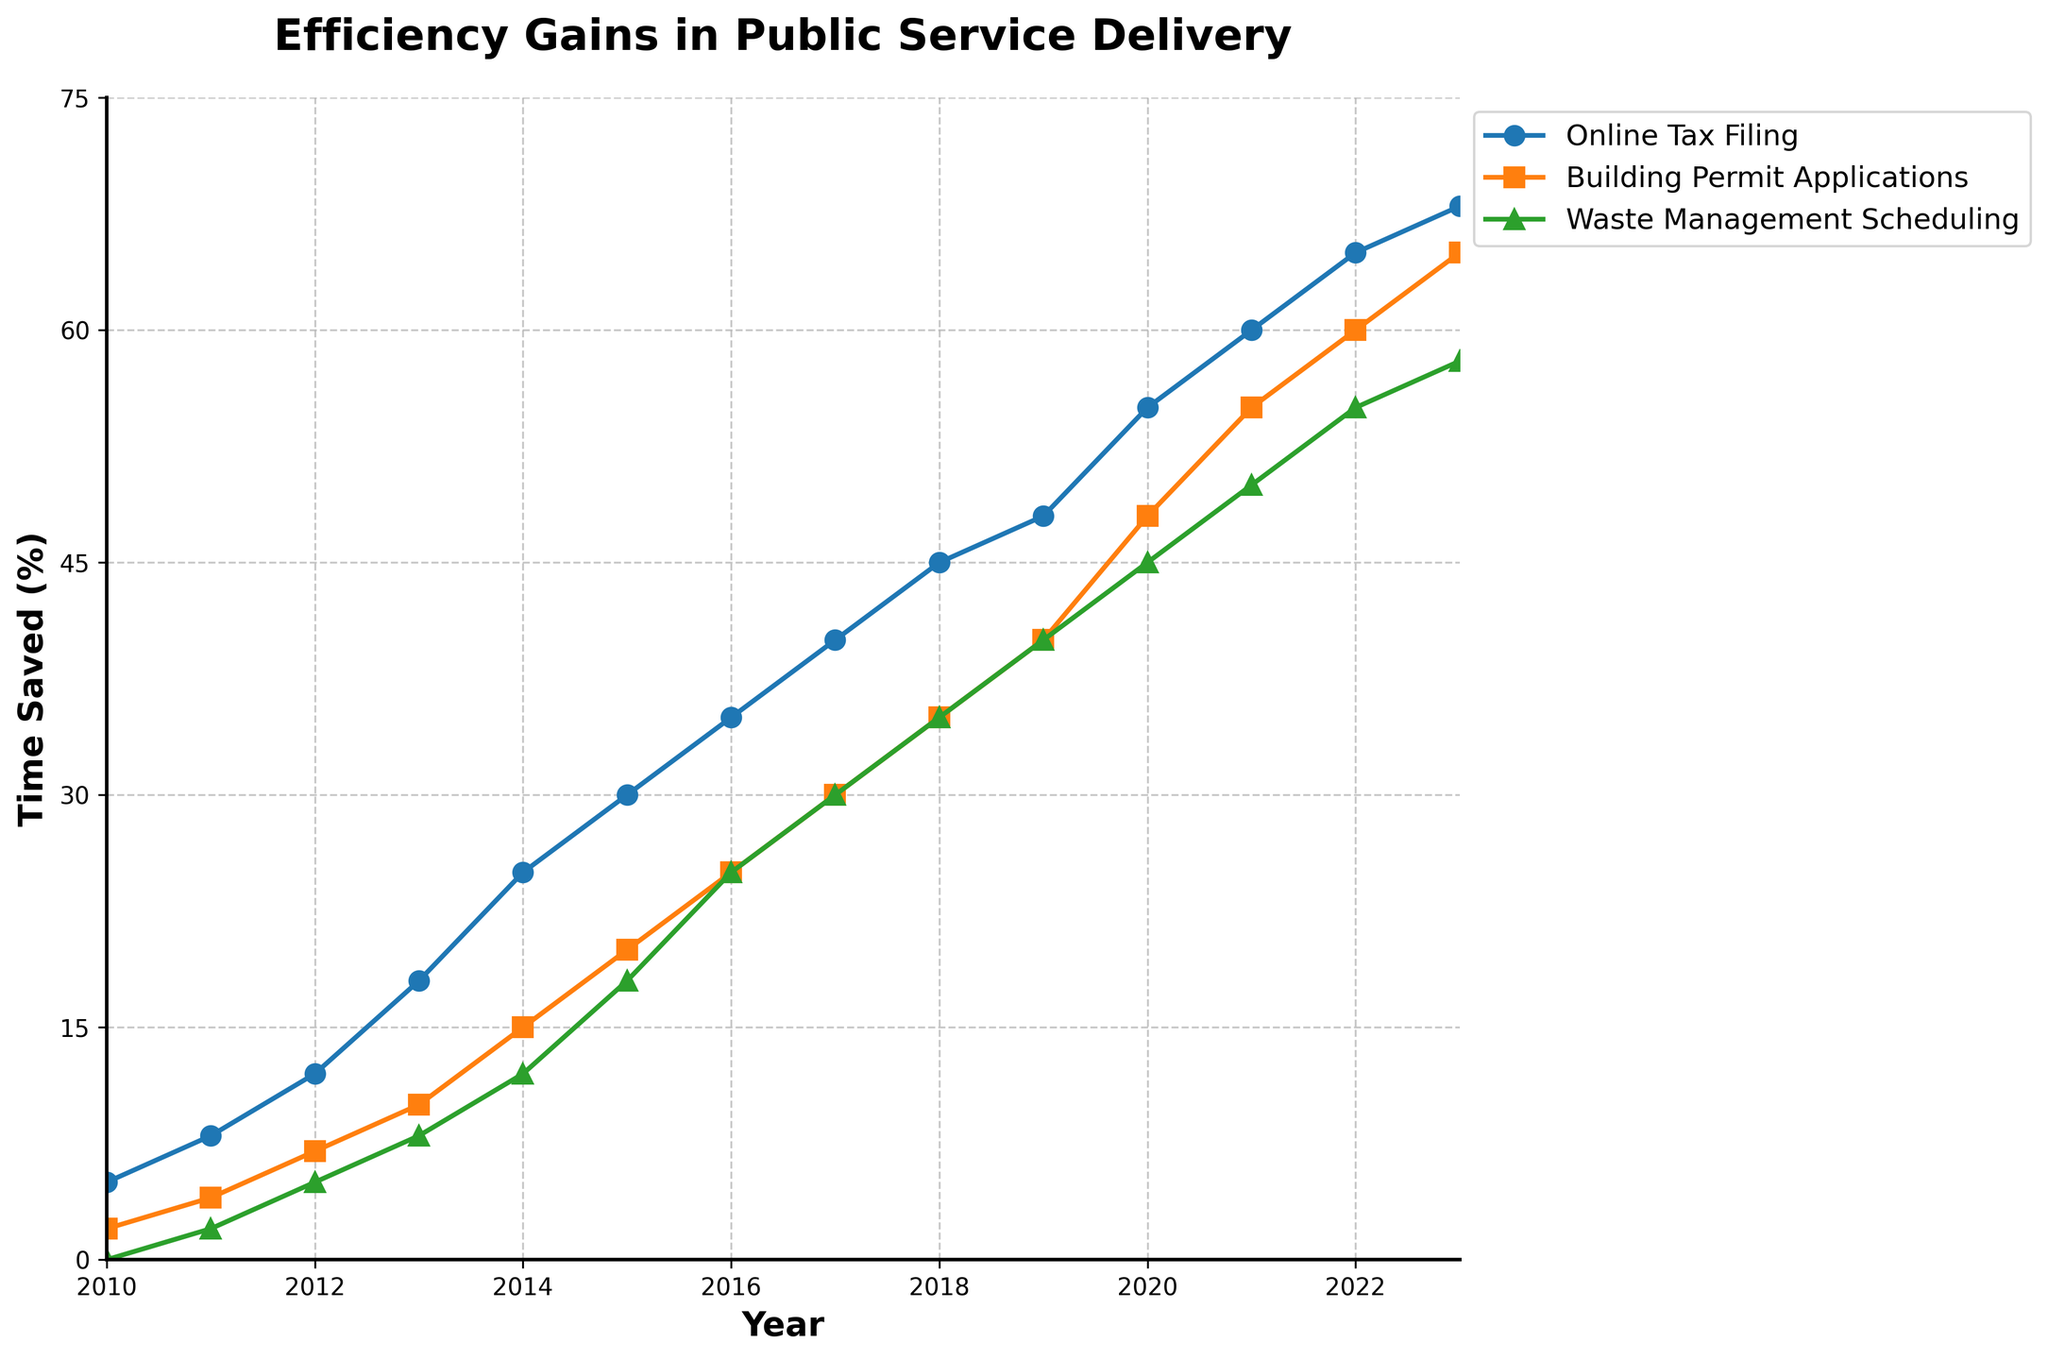what is the total percentage of time saved across all services in 2020? Add the percentages of time saved in 2020 for Online Tax Filing (55%), Building Permit Applications (48%), and Waste Management Scheduling (45%). \( 55 + 48 + 45 = 148 \)
Answer: 148% Which service saw the highest percentage time saved in 2023? Compare the percentage of time saved in 2023 for Online Tax Filing (68%), Building Permit Applications (65%), and Waste Management Scheduling (58%). 68% is the highest.
Answer: Online Tax Filing What is the average percentage time saved for Building Permit Applications from 2018 to 2022? Add the percentages of time saved for Building Permit Applications from 2018 (35%), 2019 (40%), 2020 (48%), 2021 (55%), and 2022 (60%), then divide by 5. \( (35+40+48+55+60) / 5 = 238 / 5 = 47.6 \)
Answer: 47.6% How does the time saved in Waste Management Scheduling in 2013 compare to Online Tax Filing in the same year? Note the time saved in Waste Management Scheduling (8%) and Online Tax Filing (18%) in 2013. Calculate the difference. \( 18 - 8 = 10 \). Waste Management Scheduling saved 10% less time.
Answer: 10% less From 2010 to 2023, which service consistently showed an increase in the percentage of time saved each year? Check the trend lines in the figure for Online Tax Filing, Building Permit Applications, and Waste Management Scheduling to identify which consistently increased each year from 2010 to 2023. All three services do.
Answer: All services How much did time saved in Building Permit Applications grow from 2012 to 2015? Subtract the percentage of time saved in 2012 (7%) from that in 2015 (20%). \( 20 - 7 = 13 \). The growth is 13%.
Answer: 13% What is the visual comparison between Waste Management Scheduling and Online Tax Filing in 2022? Compare the line colors and markers for Waste Management Scheduling (green, triangle) and Online Tax Filing (blue, circle) for the year 2022, noting the height of the markers on the y-axis.
Answer: Green triangle is lower What was the percentage increase in time saved for Online Tax Filing from the start to the end of the period analyzed? Subtract the percentage in 2010 (5%) from that in 2023 (68%) for Online Tax Filing. \( 68 - 5 = 63 \).
Answer: 63% 